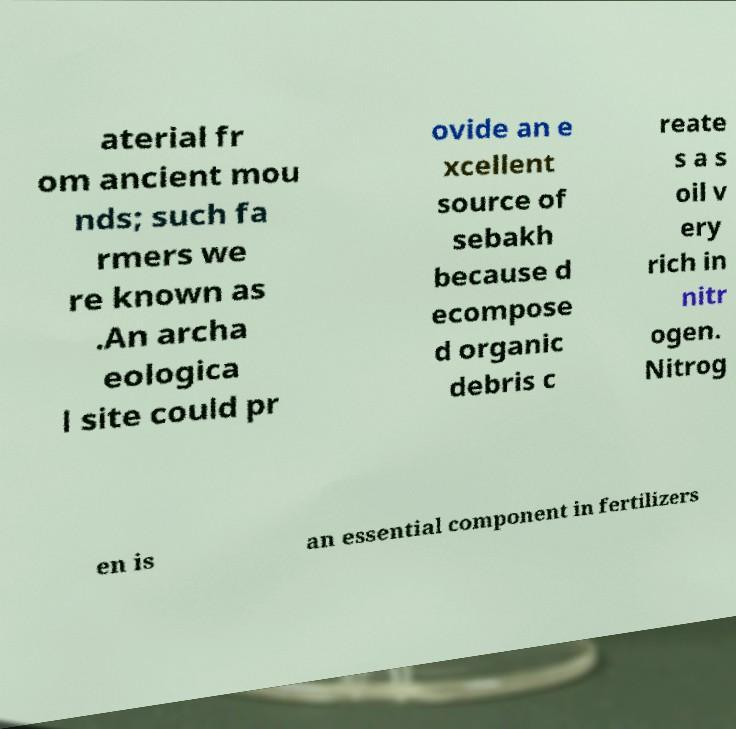Please read and relay the text visible in this image. What does it say? aterial fr om ancient mou nds; such fa rmers we re known as .An archa eologica l site could pr ovide an e xcellent source of sebakh because d ecompose d organic debris c reate s a s oil v ery rich in nitr ogen. Nitrog en is an essential component in fertilizers 